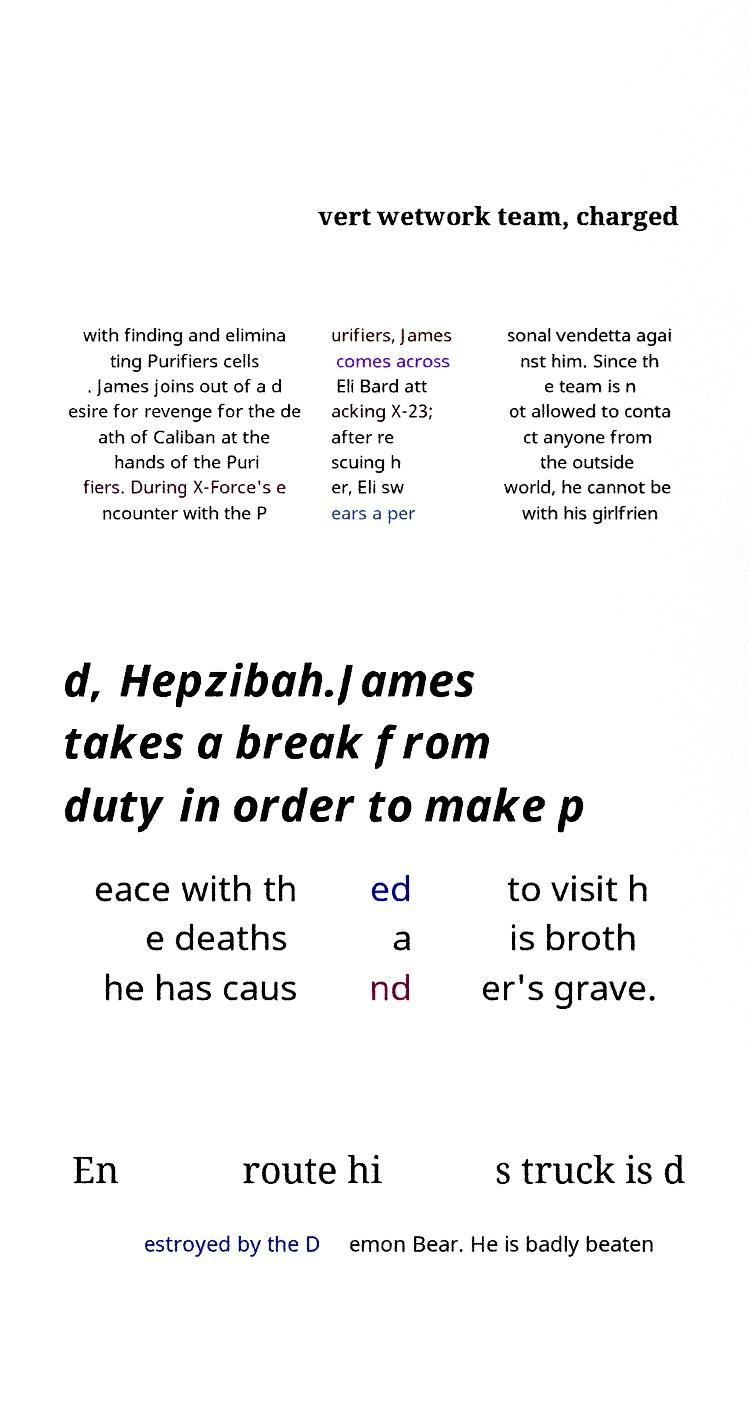Please identify and transcribe the text found in this image. vert wetwork team, charged with finding and elimina ting Purifiers cells . James joins out of a d esire for revenge for the de ath of Caliban at the hands of the Puri fiers. During X-Force's e ncounter with the P urifiers, James comes across Eli Bard att acking X-23; after re scuing h er, Eli sw ears a per sonal vendetta agai nst him. Since th e team is n ot allowed to conta ct anyone from the outside world, he cannot be with his girlfrien d, Hepzibah.James takes a break from duty in order to make p eace with th e deaths he has caus ed a nd to visit h is broth er's grave. En route hi s truck is d estroyed by the D emon Bear. He is badly beaten 